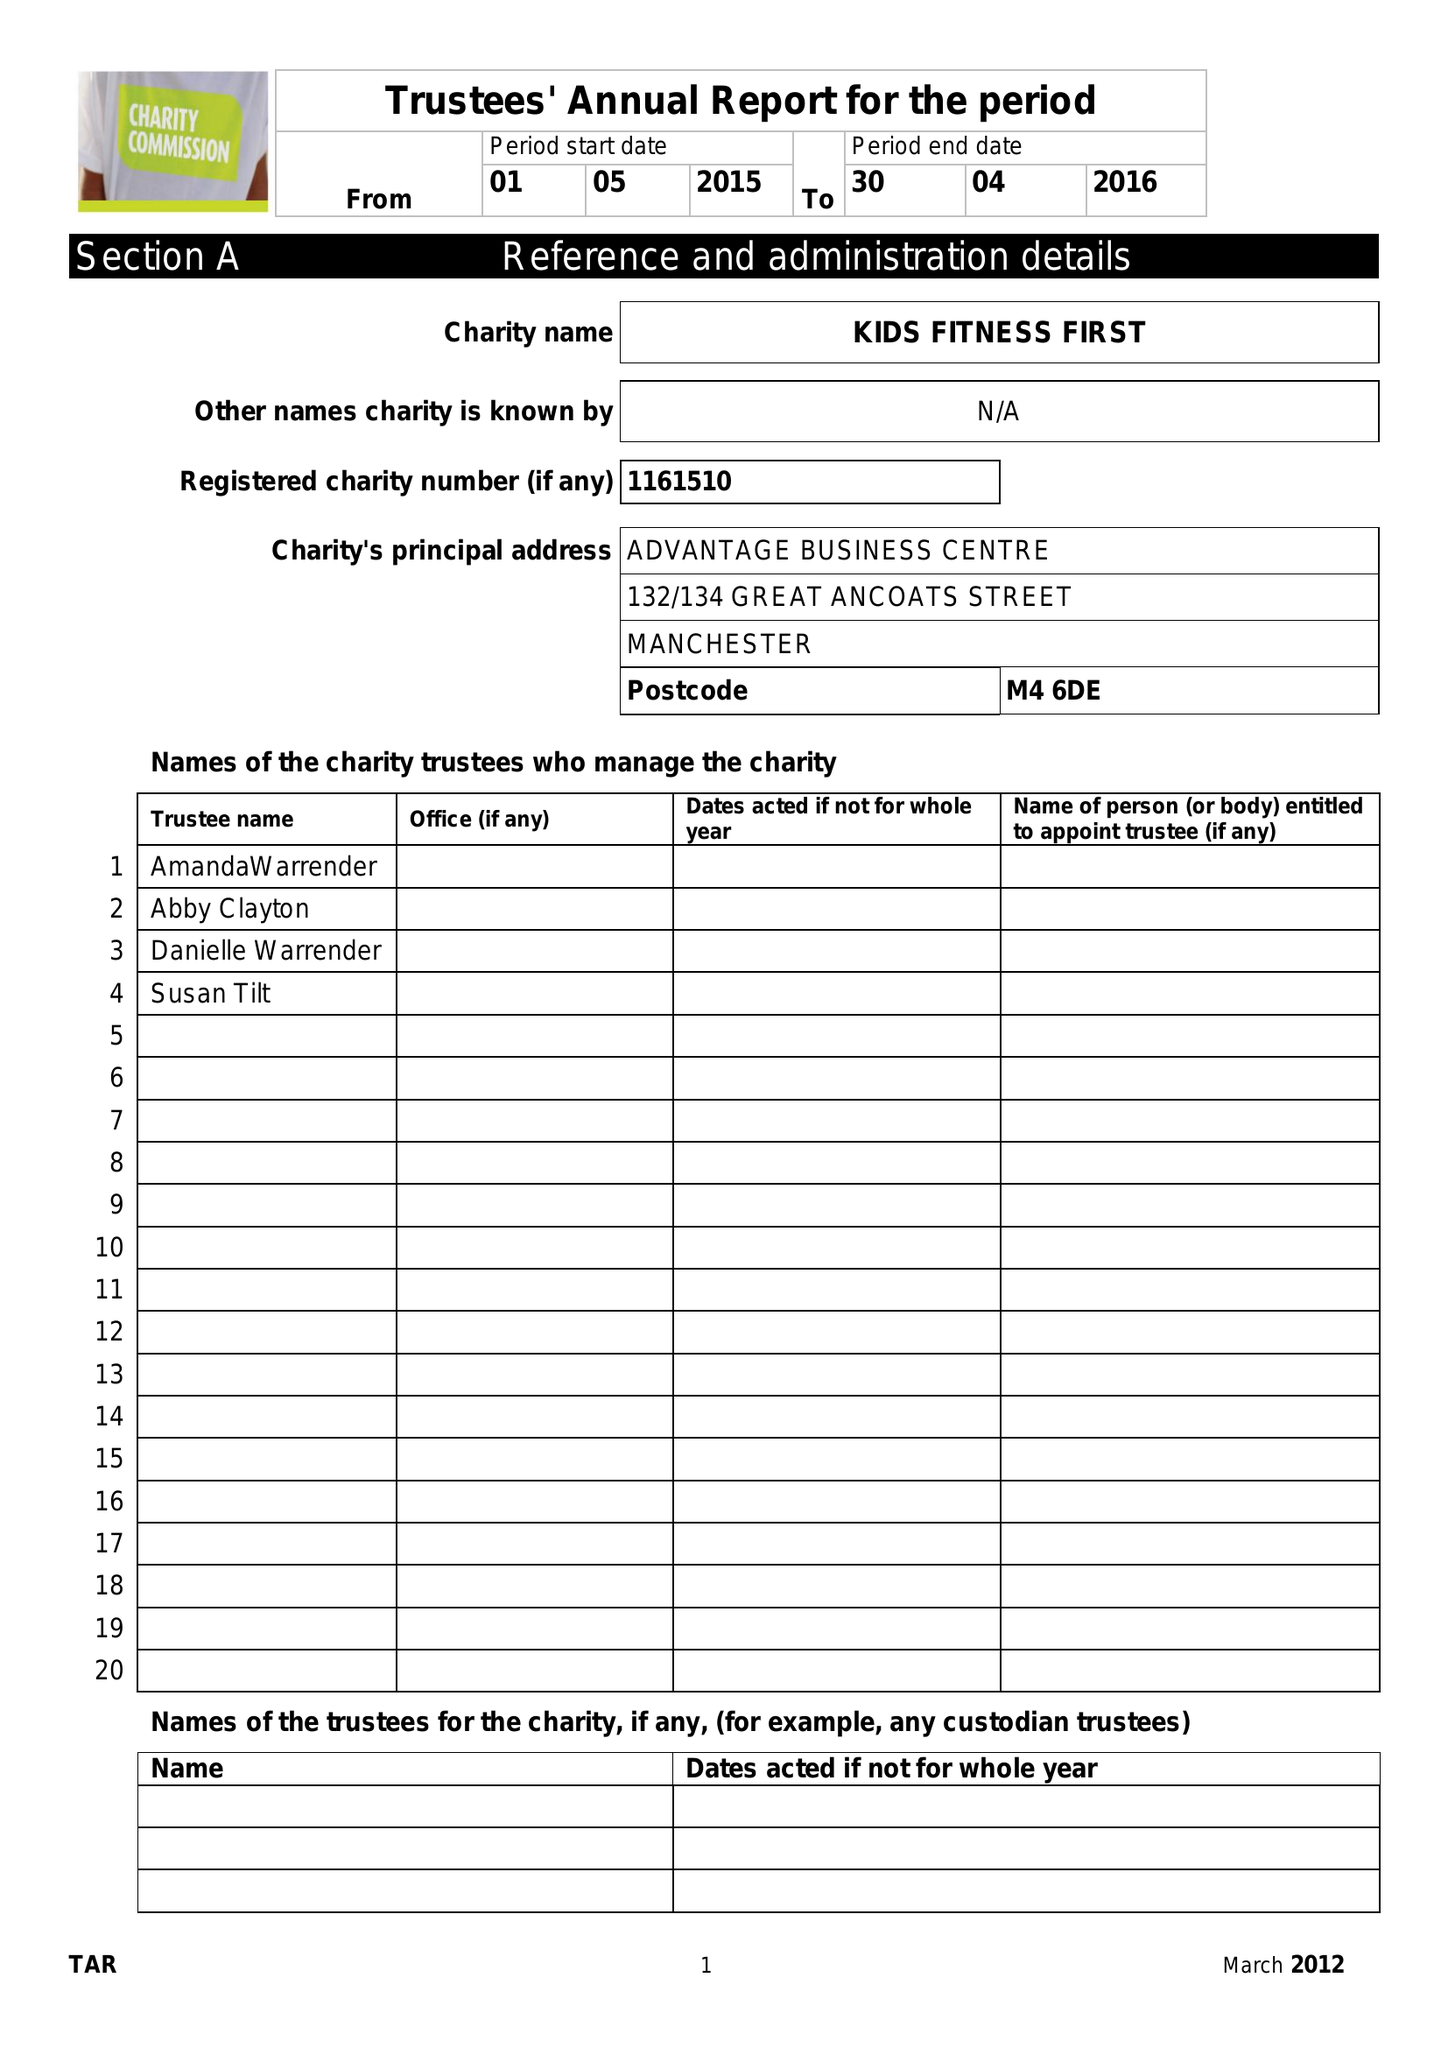What is the value for the charity_number?
Answer the question using a single word or phrase. 1161510 